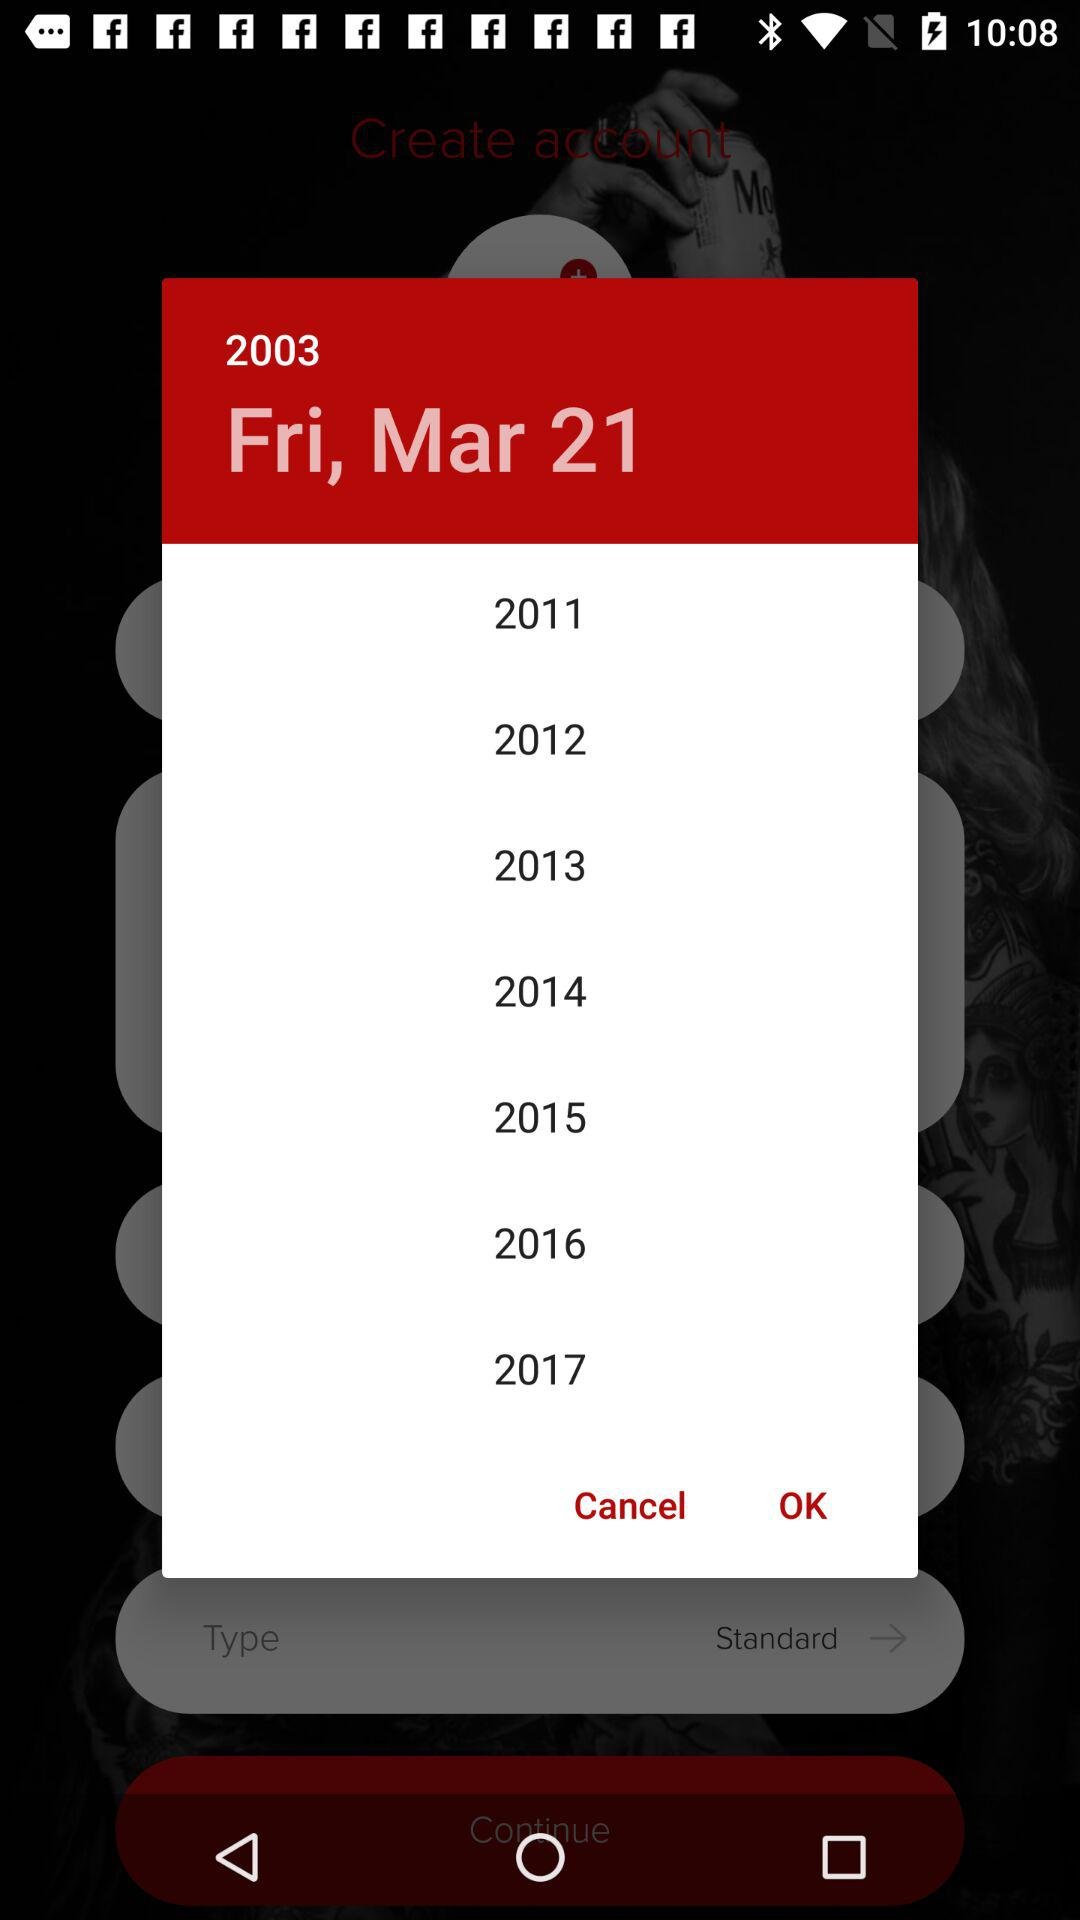What is the date? The date is Friday, March 21, 2003. 